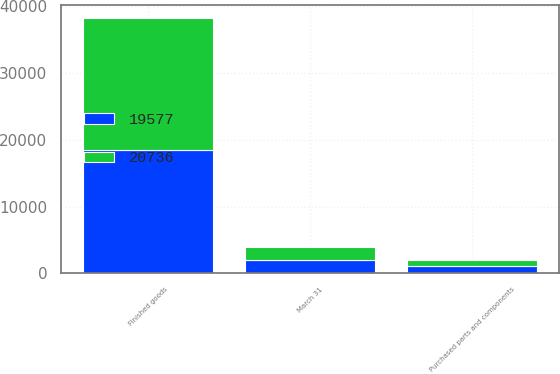<chart> <loc_0><loc_0><loc_500><loc_500><stacked_bar_chart><ecel><fcel>March 31<fcel>Purchased parts and components<fcel>Finished goods<nl><fcel>19577<fcel>2003<fcel>1129<fcel>18448<nl><fcel>20736<fcel>2002<fcel>892<fcel>19844<nl></chart> 